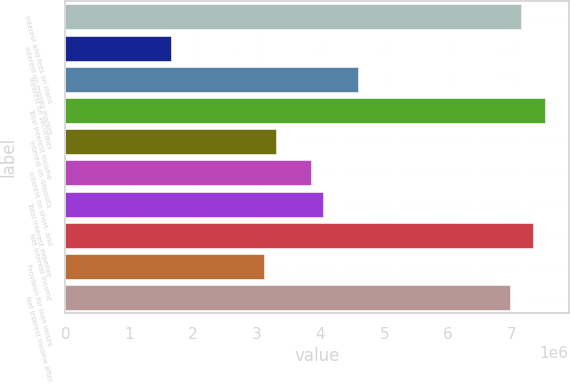Convert chart. <chart><loc_0><loc_0><loc_500><loc_500><bar_chart><fcel>Interest and fees on loans<fcel>Interest on money market<fcel>Interest on securities<fcel>Total interest income<fcel>Interest on deposits<fcel>Interest on short- and<fcel>Total interest expense<fcel>Net interest income<fcel>Provision for loan losses<fcel>Net interest income after<nl><fcel>7.15053e+06<fcel>1.65012e+06<fcel>4.58368e+06<fcel>7.51723e+06<fcel>3.30025e+06<fcel>3.85029e+06<fcel>4.03363e+06<fcel>7.33388e+06<fcel>3.1169e+06<fcel>6.96719e+06<nl></chart> 